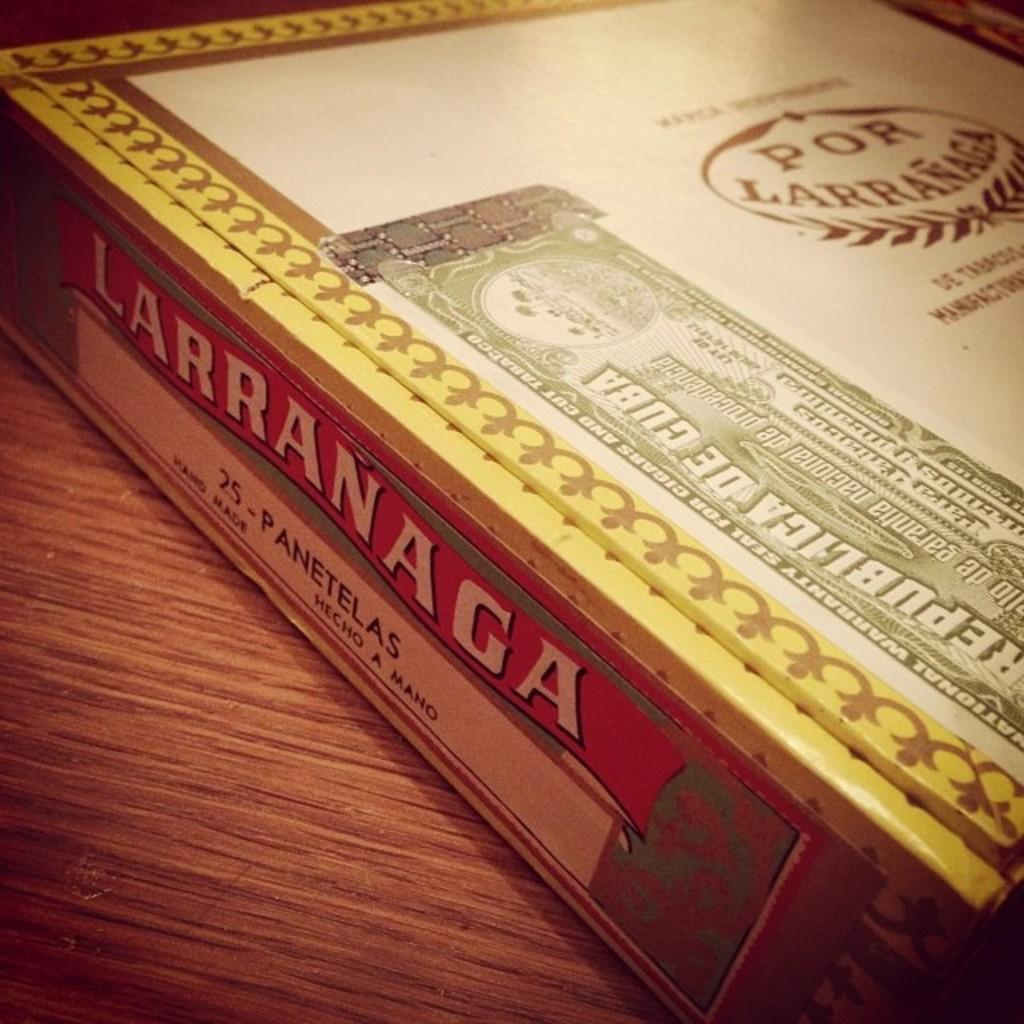Provide a one-sentence caption for the provided image. A large box of Larranaga cigars sits on a table. 